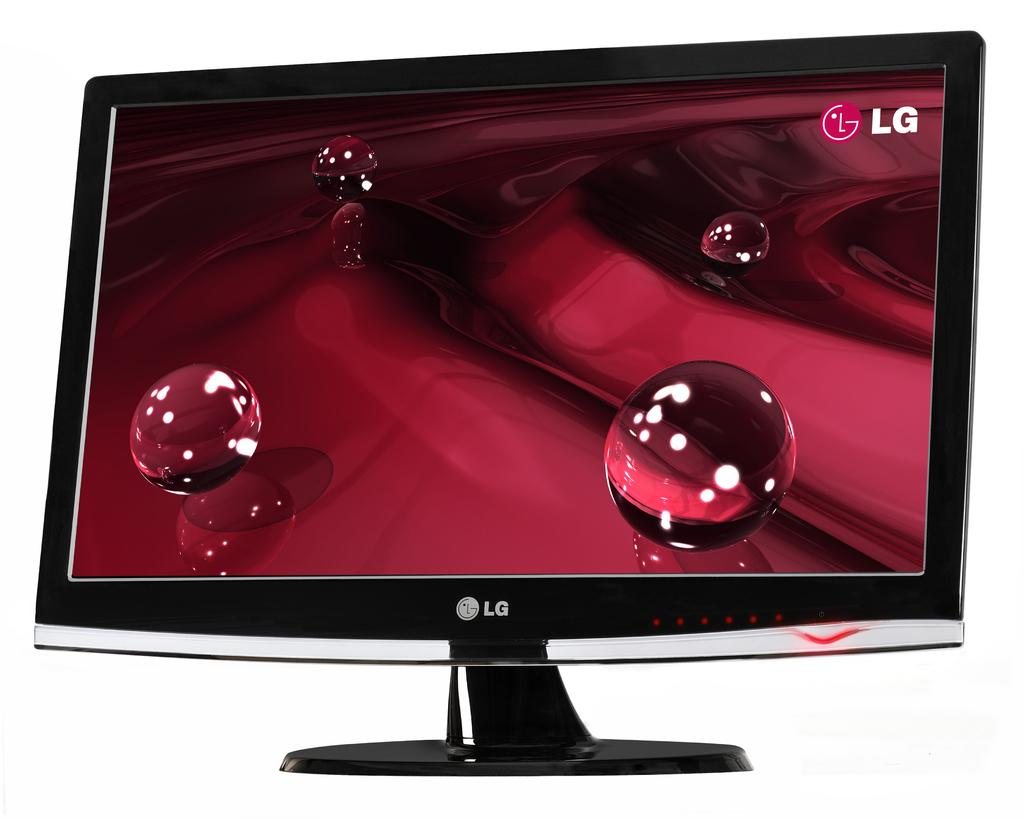<image>
Present a compact description of the photo's key features. A black computer monitor says LG on the front. 